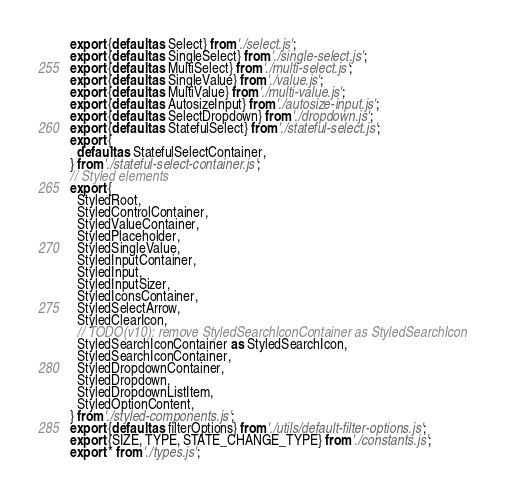Convert code to text. <code><loc_0><loc_0><loc_500><loc_500><_JavaScript_>export {default as Select} from './select.js';
export {default as SingleSelect} from './single-select.js';
export {default as MultiSelect} from './multi-select.js';
export {default as SingleValue} from './value.js';
export {default as MultiValue} from './multi-value.js';
export {default as AutosizeInput} from './autosize-input.js';
export {default as SelectDropdown} from './dropdown.js';
export {default as StatefulSelect} from './stateful-select.js';
export {
  default as StatefulSelectContainer,
} from './stateful-select-container.js';
// Styled elements
export {
  StyledRoot,
  StyledControlContainer,
  StyledValueContainer,
  StyledPlaceholder,
  StyledSingleValue,
  StyledInputContainer,
  StyledInput,
  StyledInputSizer,
  StyledIconsContainer,
  StyledSelectArrow,
  StyledClearIcon,
  // TODO(v10): remove StyledSearchIconContainer as StyledSearchIcon
  StyledSearchIconContainer as StyledSearchIcon,
  StyledSearchIconContainer,
  StyledDropdownContainer,
  StyledDropdown,
  StyledDropdownListItem,
  StyledOptionContent,
} from './styled-components.js';
export {default as filterOptions} from './utils/default-filter-options.js';
export {SIZE, TYPE, STATE_CHANGE_TYPE} from './constants.js';
export * from './types.js';
</code> 